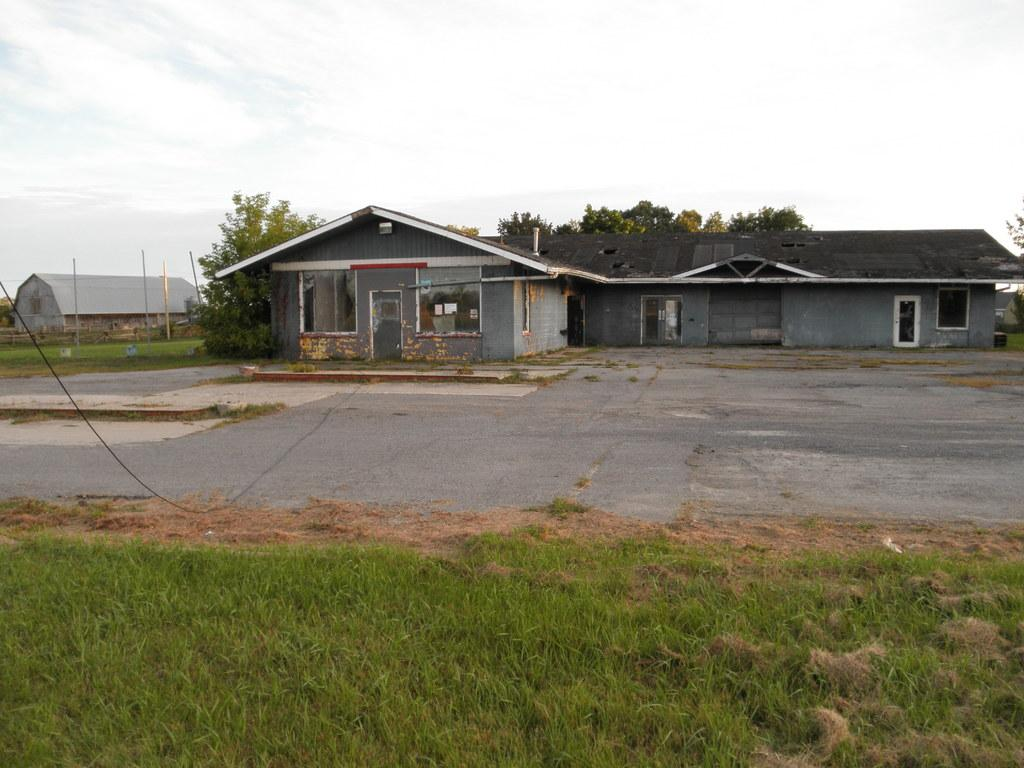What type of structures can be seen in the image? There are buildings in the image. What type of vegetation is visible in the image? There is grass visible in the image. What type of pathway is present in the image? There is a road in the image. What can be seen in the background of the image? There are trees, poles, and the sky visible in the background of the image. How many sisters are sitting on the quilt in the image? There is no quilt or sisters present in the image. What type of sorting activity is taking place in the image? There is no sorting activity present in the image. 